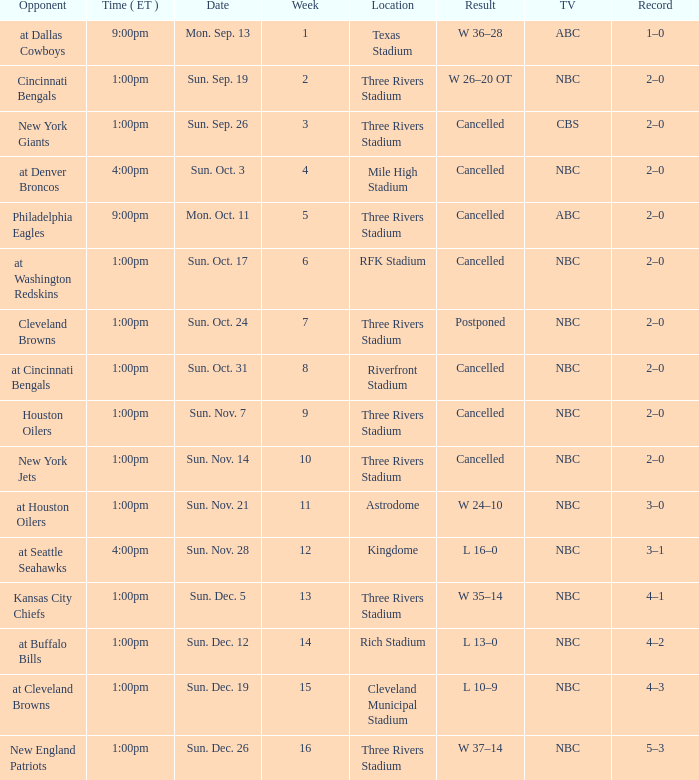What time in eastern standard time was game held at denver broncos? 4:00pm. 